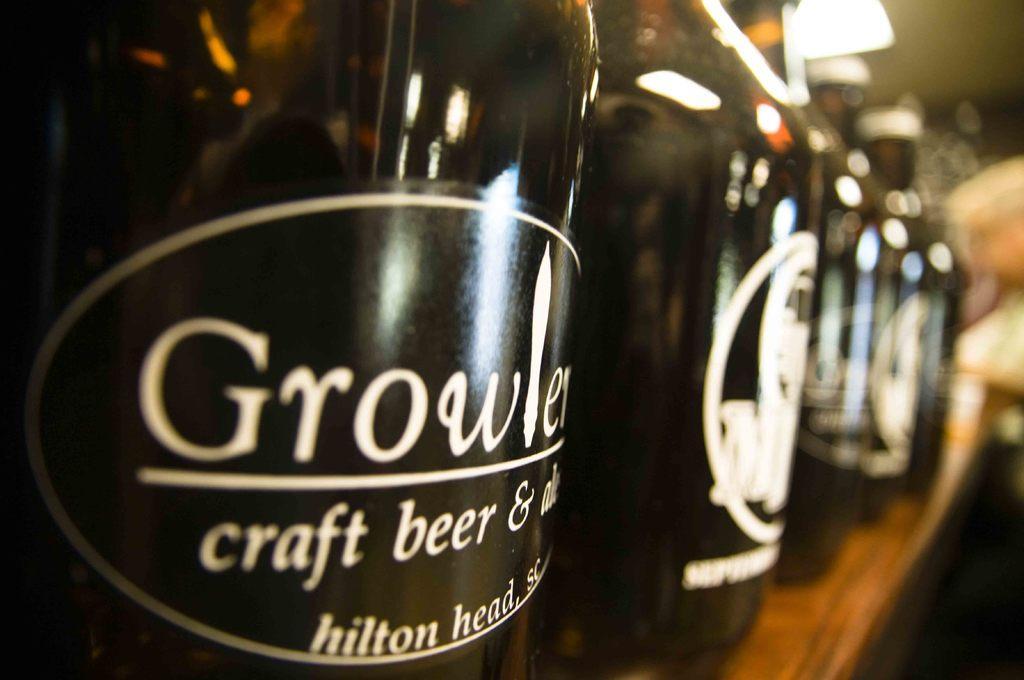How would you summarize this image in a sentence or two? In this image I can see the bottles on the brown color surface. I can see the blurred background. 